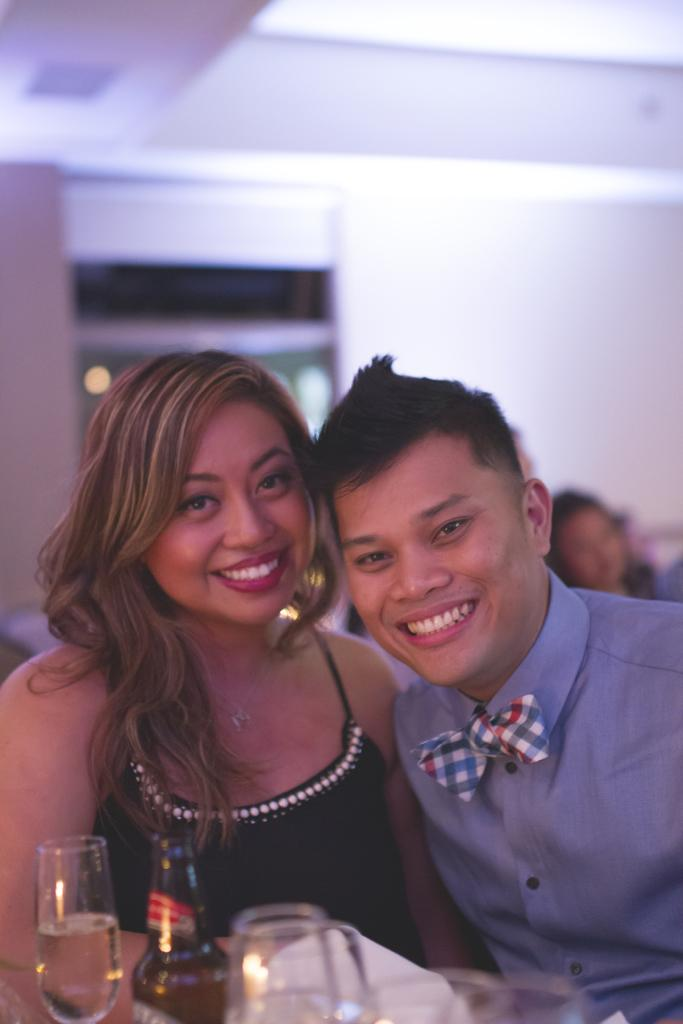How many people are present in the image? There are two people sitting in the image. What is the facial expression of the people in the image? The people are smiling. What type of beverage container is present in the image? There is a bottle in the image. What is inside the glass in the image? There is water in the glass. What type of structure is visible in the image? There is a wall and a roof in the image. What type of chalk is being used to draw on the card in the image? There is no chalk or card present in the image. What type of room is visible in the image? The image does not show a room; it only shows two people, glasses, a bottle, a wall, and a roof. 